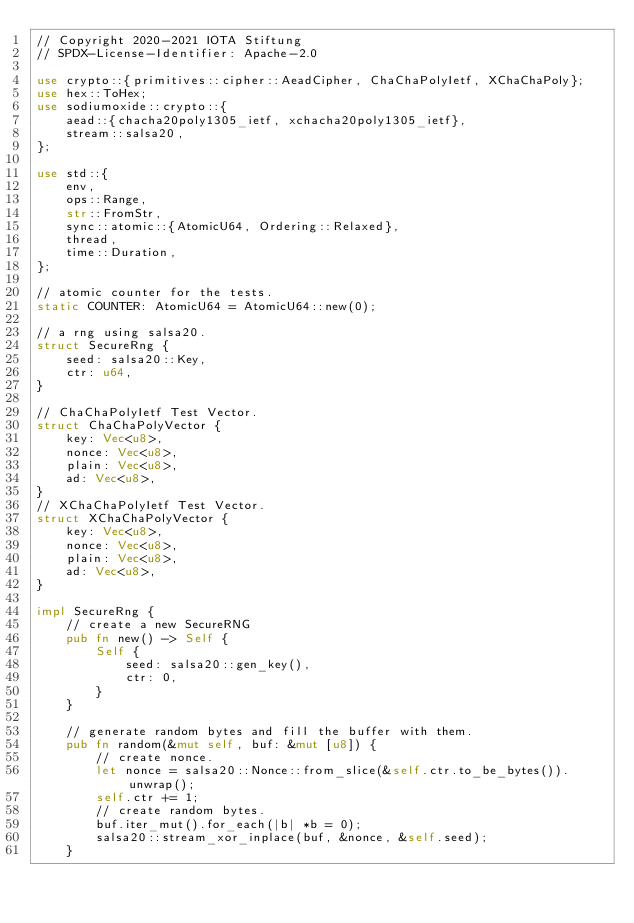Convert code to text. <code><loc_0><loc_0><loc_500><loc_500><_Rust_>// Copyright 2020-2021 IOTA Stiftung
// SPDX-License-Identifier: Apache-2.0

use crypto::{primitives::cipher::AeadCipher, ChaChaPolyIetf, XChaChaPoly};
use hex::ToHex;
use sodiumoxide::crypto::{
    aead::{chacha20poly1305_ietf, xchacha20poly1305_ietf},
    stream::salsa20,
};

use std::{
    env,
    ops::Range,
    str::FromStr,
    sync::atomic::{AtomicU64, Ordering::Relaxed},
    thread,
    time::Duration,
};

// atomic counter for the tests.
static COUNTER: AtomicU64 = AtomicU64::new(0);

// a rng using salsa20.
struct SecureRng {
    seed: salsa20::Key,
    ctr: u64,
}

// ChaChaPolyIetf Test Vector.
struct ChaChaPolyVector {
    key: Vec<u8>,
    nonce: Vec<u8>,
    plain: Vec<u8>,
    ad: Vec<u8>,
}
// XChaChaPolyIetf Test Vector.
struct XChaChaPolyVector {
    key: Vec<u8>,
    nonce: Vec<u8>,
    plain: Vec<u8>,
    ad: Vec<u8>,
}

impl SecureRng {
    // create a new SecureRNG
    pub fn new() -> Self {
        Self {
            seed: salsa20::gen_key(),
            ctr: 0,
        }
    }

    // generate random bytes and fill the buffer with them.
    pub fn random(&mut self, buf: &mut [u8]) {
        // create nonce.
        let nonce = salsa20::Nonce::from_slice(&self.ctr.to_be_bytes()).unwrap();
        self.ctr += 1;
        // create random bytes.
        buf.iter_mut().for_each(|b| *b = 0);
        salsa20::stream_xor_inplace(buf, &nonce, &self.seed);
    }
</code> 